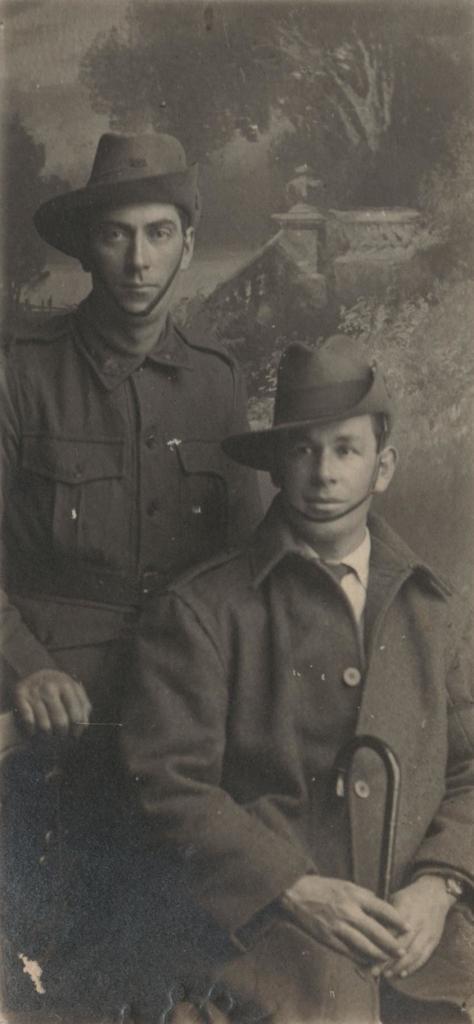Describe this image in one or two sentences. This picture seems to be an edited image. In the foreground we can see a person wearing a hat, holding an object and seems to be sitting. On the left we can see another person seems to be wearing a shirt and standing. In the background we can see the depictions of the trees and the depictions of some objects. 